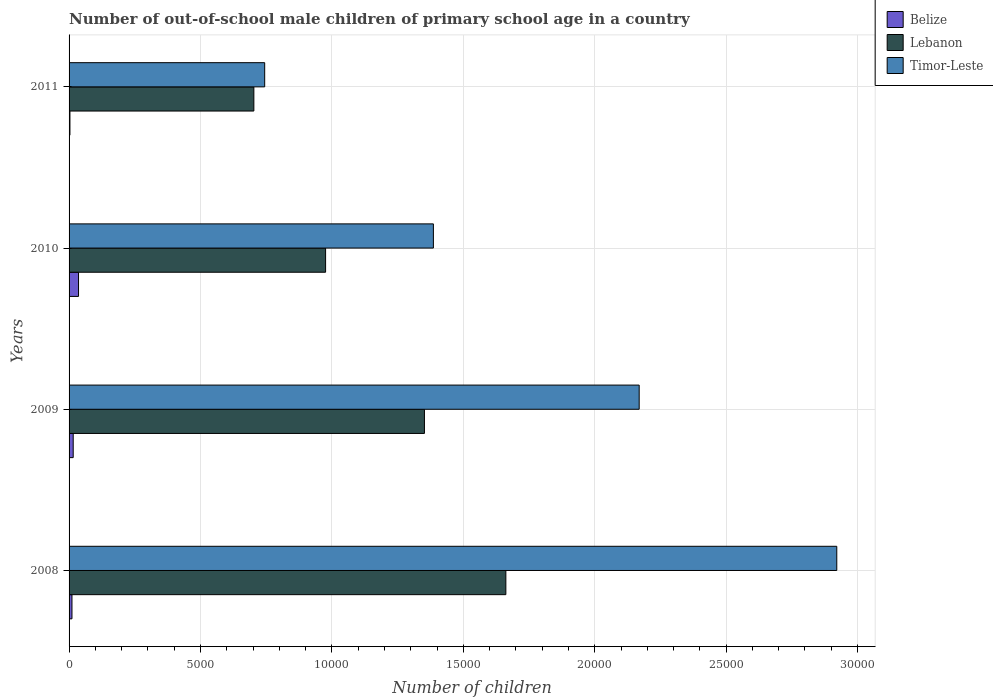Are the number of bars on each tick of the Y-axis equal?
Your response must be concise. Yes. How many bars are there on the 1st tick from the top?
Your answer should be very brief. 3. What is the label of the 2nd group of bars from the top?
Give a very brief answer. 2010. What is the number of out-of-school male children in Timor-Leste in 2009?
Ensure brevity in your answer.  2.17e+04. Across all years, what is the maximum number of out-of-school male children in Belize?
Give a very brief answer. 360. Across all years, what is the minimum number of out-of-school male children in Lebanon?
Provide a succinct answer. 7031. In which year was the number of out-of-school male children in Lebanon maximum?
Provide a succinct answer. 2008. In which year was the number of out-of-school male children in Belize minimum?
Provide a short and direct response. 2011. What is the total number of out-of-school male children in Lebanon in the graph?
Give a very brief answer. 4.69e+04. What is the difference between the number of out-of-school male children in Belize in 2010 and that in 2011?
Provide a succinct answer. 327. What is the difference between the number of out-of-school male children in Timor-Leste in 2009 and the number of out-of-school male children in Lebanon in 2011?
Provide a short and direct response. 1.47e+04. What is the average number of out-of-school male children in Belize per year?
Provide a succinct answer. 165. In the year 2009, what is the difference between the number of out-of-school male children in Timor-Leste and number of out-of-school male children in Lebanon?
Provide a succinct answer. 8171. In how many years, is the number of out-of-school male children in Lebanon greater than 22000 ?
Give a very brief answer. 0. What is the ratio of the number of out-of-school male children in Timor-Leste in 2010 to that in 2011?
Provide a short and direct response. 1.86. What is the difference between the highest and the second highest number of out-of-school male children in Belize?
Offer a terse response. 203. What is the difference between the highest and the lowest number of out-of-school male children in Lebanon?
Your response must be concise. 9588. What does the 2nd bar from the top in 2009 represents?
Ensure brevity in your answer.  Lebanon. What does the 3rd bar from the bottom in 2008 represents?
Make the answer very short. Timor-Leste. How many bars are there?
Your answer should be compact. 12. How many years are there in the graph?
Ensure brevity in your answer.  4. What is the difference between two consecutive major ticks on the X-axis?
Give a very brief answer. 5000. Are the values on the major ticks of X-axis written in scientific E-notation?
Provide a short and direct response. No. Does the graph contain any zero values?
Your answer should be very brief. No. Where does the legend appear in the graph?
Your answer should be compact. Top right. How are the legend labels stacked?
Give a very brief answer. Vertical. What is the title of the graph?
Your answer should be very brief. Number of out-of-school male children of primary school age in a country. What is the label or title of the X-axis?
Make the answer very short. Number of children. What is the Number of children in Belize in 2008?
Offer a terse response. 110. What is the Number of children of Lebanon in 2008?
Offer a very short reply. 1.66e+04. What is the Number of children of Timor-Leste in 2008?
Offer a terse response. 2.92e+04. What is the Number of children in Belize in 2009?
Give a very brief answer. 157. What is the Number of children of Lebanon in 2009?
Ensure brevity in your answer.  1.35e+04. What is the Number of children of Timor-Leste in 2009?
Your answer should be compact. 2.17e+04. What is the Number of children in Belize in 2010?
Make the answer very short. 360. What is the Number of children of Lebanon in 2010?
Your response must be concise. 9760. What is the Number of children of Timor-Leste in 2010?
Provide a short and direct response. 1.39e+04. What is the Number of children in Belize in 2011?
Offer a terse response. 33. What is the Number of children of Lebanon in 2011?
Offer a very short reply. 7031. What is the Number of children in Timor-Leste in 2011?
Make the answer very short. 7443. Across all years, what is the maximum Number of children of Belize?
Provide a short and direct response. 360. Across all years, what is the maximum Number of children of Lebanon?
Make the answer very short. 1.66e+04. Across all years, what is the maximum Number of children of Timor-Leste?
Offer a terse response. 2.92e+04. Across all years, what is the minimum Number of children in Lebanon?
Your answer should be compact. 7031. Across all years, what is the minimum Number of children of Timor-Leste?
Give a very brief answer. 7443. What is the total Number of children in Belize in the graph?
Provide a short and direct response. 660. What is the total Number of children of Lebanon in the graph?
Offer a terse response. 4.69e+04. What is the total Number of children of Timor-Leste in the graph?
Provide a short and direct response. 7.22e+04. What is the difference between the Number of children in Belize in 2008 and that in 2009?
Offer a very short reply. -47. What is the difference between the Number of children in Lebanon in 2008 and that in 2009?
Ensure brevity in your answer.  3098. What is the difference between the Number of children in Timor-Leste in 2008 and that in 2009?
Provide a succinct answer. 7518. What is the difference between the Number of children in Belize in 2008 and that in 2010?
Ensure brevity in your answer.  -250. What is the difference between the Number of children of Lebanon in 2008 and that in 2010?
Provide a short and direct response. 6859. What is the difference between the Number of children in Timor-Leste in 2008 and that in 2010?
Ensure brevity in your answer.  1.53e+04. What is the difference between the Number of children of Lebanon in 2008 and that in 2011?
Give a very brief answer. 9588. What is the difference between the Number of children of Timor-Leste in 2008 and that in 2011?
Make the answer very short. 2.18e+04. What is the difference between the Number of children of Belize in 2009 and that in 2010?
Your answer should be compact. -203. What is the difference between the Number of children of Lebanon in 2009 and that in 2010?
Ensure brevity in your answer.  3761. What is the difference between the Number of children in Timor-Leste in 2009 and that in 2010?
Provide a short and direct response. 7830. What is the difference between the Number of children in Belize in 2009 and that in 2011?
Your answer should be very brief. 124. What is the difference between the Number of children of Lebanon in 2009 and that in 2011?
Provide a short and direct response. 6490. What is the difference between the Number of children in Timor-Leste in 2009 and that in 2011?
Your answer should be compact. 1.42e+04. What is the difference between the Number of children in Belize in 2010 and that in 2011?
Make the answer very short. 327. What is the difference between the Number of children of Lebanon in 2010 and that in 2011?
Keep it short and to the point. 2729. What is the difference between the Number of children in Timor-Leste in 2010 and that in 2011?
Provide a succinct answer. 6419. What is the difference between the Number of children of Belize in 2008 and the Number of children of Lebanon in 2009?
Your response must be concise. -1.34e+04. What is the difference between the Number of children in Belize in 2008 and the Number of children in Timor-Leste in 2009?
Your answer should be very brief. -2.16e+04. What is the difference between the Number of children in Lebanon in 2008 and the Number of children in Timor-Leste in 2009?
Offer a terse response. -5073. What is the difference between the Number of children of Belize in 2008 and the Number of children of Lebanon in 2010?
Keep it short and to the point. -9650. What is the difference between the Number of children in Belize in 2008 and the Number of children in Timor-Leste in 2010?
Offer a very short reply. -1.38e+04. What is the difference between the Number of children in Lebanon in 2008 and the Number of children in Timor-Leste in 2010?
Ensure brevity in your answer.  2757. What is the difference between the Number of children in Belize in 2008 and the Number of children in Lebanon in 2011?
Provide a succinct answer. -6921. What is the difference between the Number of children in Belize in 2008 and the Number of children in Timor-Leste in 2011?
Ensure brevity in your answer.  -7333. What is the difference between the Number of children in Lebanon in 2008 and the Number of children in Timor-Leste in 2011?
Keep it short and to the point. 9176. What is the difference between the Number of children of Belize in 2009 and the Number of children of Lebanon in 2010?
Ensure brevity in your answer.  -9603. What is the difference between the Number of children in Belize in 2009 and the Number of children in Timor-Leste in 2010?
Ensure brevity in your answer.  -1.37e+04. What is the difference between the Number of children in Lebanon in 2009 and the Number of children in Timor-Leste in 2010?
Provide a succinct answer. -341. What is the difference between the Number of children in Belize in 2009 and the Number of children in Lebanon in 2011?
Offer a very short reply. -6874. What is the difference between the Number of children in Belize in 2009 and the Number of children in Timor-Leste in 2011?
Offer a terse response. -7286. What is the difference between the Number of children in Lebanon in 2009 and the Number of children in Timor-Leste in 2011?
Ensure brevity in your answer.  6078. What is the difference between the Number of children in Belize in 2010 and the Number of children in Lebanon in 2011?
Your response must be concise. -6671. What is the difference between the Number of children in Belize in 2010 and the Number of children in Timor-Leste in 2011?
Make the answer very short. -7083. What is the difference between the Number of children of Lebanon in 2010 and the Number of children of Timor-Leste in 2011?
Make the answer very short. 2317. What is the average Number of children in Belize per year?
Your response must be concise. 165. What is the average Number of children in Lebanon per year?
Offer a very short reply. 1.17e+04. What is the average Number of children of Timor-Leste per year?
Ensure brevity in your answer.  1.81e+04. In the year 2008, what is the difference between the Number of children of Belize and Number of children of Lebanon?
Offer a very short reply. -1.65e+04. In the year 2008, what is the difference between the Number of children in Belize and Number of children in Timor-Leste?
Ensure brevity in your answer.  -2.91e+04. In the year 2008, what is the difference between the Number of children of Lebanon and Number of children of Timor-Leste?
Your answer should be very brief. -1.26e+04. In the year 2009, what is the difference between the Number of children of Belize and Number of children of Lebanon?
Provide a succinct answer. -1.34e+04. In the year 2009, what is the difference between the Number of children in Belize and Number of children in Timor-Leste?
Give a very brief answer. -2.15e+04. In the year 2009, what is the difference between the Number of children in Lebanon and Number of children in Timor-Leste?
Offer a very short reply. -8171. In the year 2010, what is the difference between the Number of children of Belize and Number of children of Lebanon?
Provide a succinct answer. -9400. In the year 2010, what is the difference between the Number of children of Belize and Number of children of Timor-Leste?
Give a very brief answer. -1.35e+04. In the year 2010, what is the difference between the Number of children in Lebanon and Number of children in Timor-Leste?
Make the answer very short. -4102. In the year 2011, what is the difference between the Number of children in Belize and Number of children in Lebanon?
Make the answer very short. -6998. In the year 2011, what is the difference between the Number of children in Belize and Number of children in Timor-Leste?
Keep it short and to the point. -7410. In the year 2011, what is the difference between the Number of children in Lebanon and Number of children in Timor-Leste?
Give a very brief answer. -412. What is the ratio of the Number of children in Belize in 2008 to that in 2009?
Your answer should be compact. 0.7. What is the ratio of the Number of children of Lebanon in 2008 to that in 2009?
Offer a very short reply. 1.23. What is the ratio of the Number of children in Timor-Leste in 2008 to that in 2009?
Your answer should be compact. 1.35. What is the ratio of the Number of children in Belize in 2008 to that in 2010?
Provide a succinct answer. 0.31. What is the ratio of the Number of children of Lebanon in 2008 to that in 2010?
Give a very brief answer. 1.7. What is the ratio of the Number of children of Timor-Leste in 2008 to that in 2010?
Keep it short and to the point. 2.11. What is the ratio of the Number of children of Belize in 2008 to that in 2011?
Your answer should be compact. 3.33. What is the ratio of the Number of children in Lebanon in 2008 to that in 2011?
Your response must be concise. 2.36. What is the ratio of the Number of children in Timor-Leste in 2008 to that in 2011?
Offer a very short reply. 3.92. What is the ratio of the Number of children in Belize in 2009 to that in 2010?
Provide a succinct answer. 0.44. What is the ratio of the Number of children of Lebanon in 2009 to that in 2010?
Your answer should be very brief. 1.39. What is the ratio of the Number of children in Timor-Leste in 2009 to that in 2010?
Provide a short and direct response. 1.56. What is the ratio of the Number of children of Belize in 2009 to that in 2011?
Make the answer very short. 4.76. What is the ratio of the Number of children in Lebanon in 2009 to that in 2011?
Ensure brevity in your answer.  1.92. What is the ratio of the Number of children of Timor-Leste in 2009 to that in 2011?
Your answer should be very brief. 2.91. What is the ratio of the Number of children in Belize in 2010 to that in 2011?
Your answer should be very brief. 10.91. What is the ratio of the Number of children in Lebanon in 2010 to that in 2011?
Make the answer very short. 1.39. What is the ratio of the Number of children in Timor-Leste in 2010 to that in 2011?
Your answer should be compact. 1.86. What is the difference between the highest and the second highest Number of children in Belize?
Provide a succinct answer. 203. What is the difference between the highest and the second highest Number of children in Lebanon?
Keep it short and to the point. 3098. What is the difference between the highest and the second highest Number of children of Timor-Leste?
Offer a very short reply. 7518. What is the difference between the highest and the lowest Number of children in Belize?
Your answer should be very brief. 327. What is the difference between the highest and the lowest Number of children of Lebanon?
Ensure brevity in your answer.  9588. What is the difference between the highest and the lowest Number of children in Timor-Leste?
Your answer should be compact. 2.18e+04. 